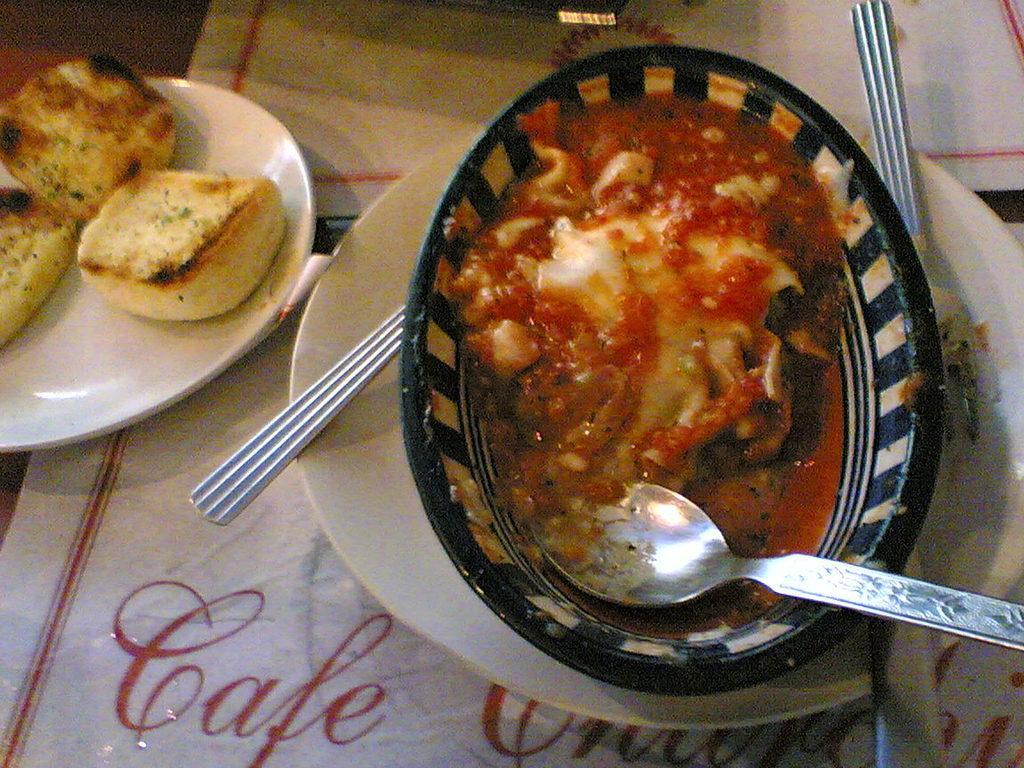Could you give a brief overview of what you see in this image? In the picture we can see a table with a table cloth on it, we can see a plate with a black color bowl on it and in it we can see a curry and spoon in it and in the plate also we can see two spoons and beside the plate we can see another plate with three cookies in it. 